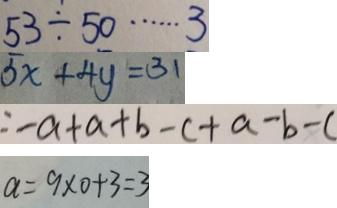<formula> <loc_0><loc_0><loc_500><loc_500>5 3 \div 5 0 \cdots 3 
 5 x + 4 y = 3 1 
 = - a + a + b - c + a - b - c 
 a = 9 \times 0 + 3 = 3</formula> 